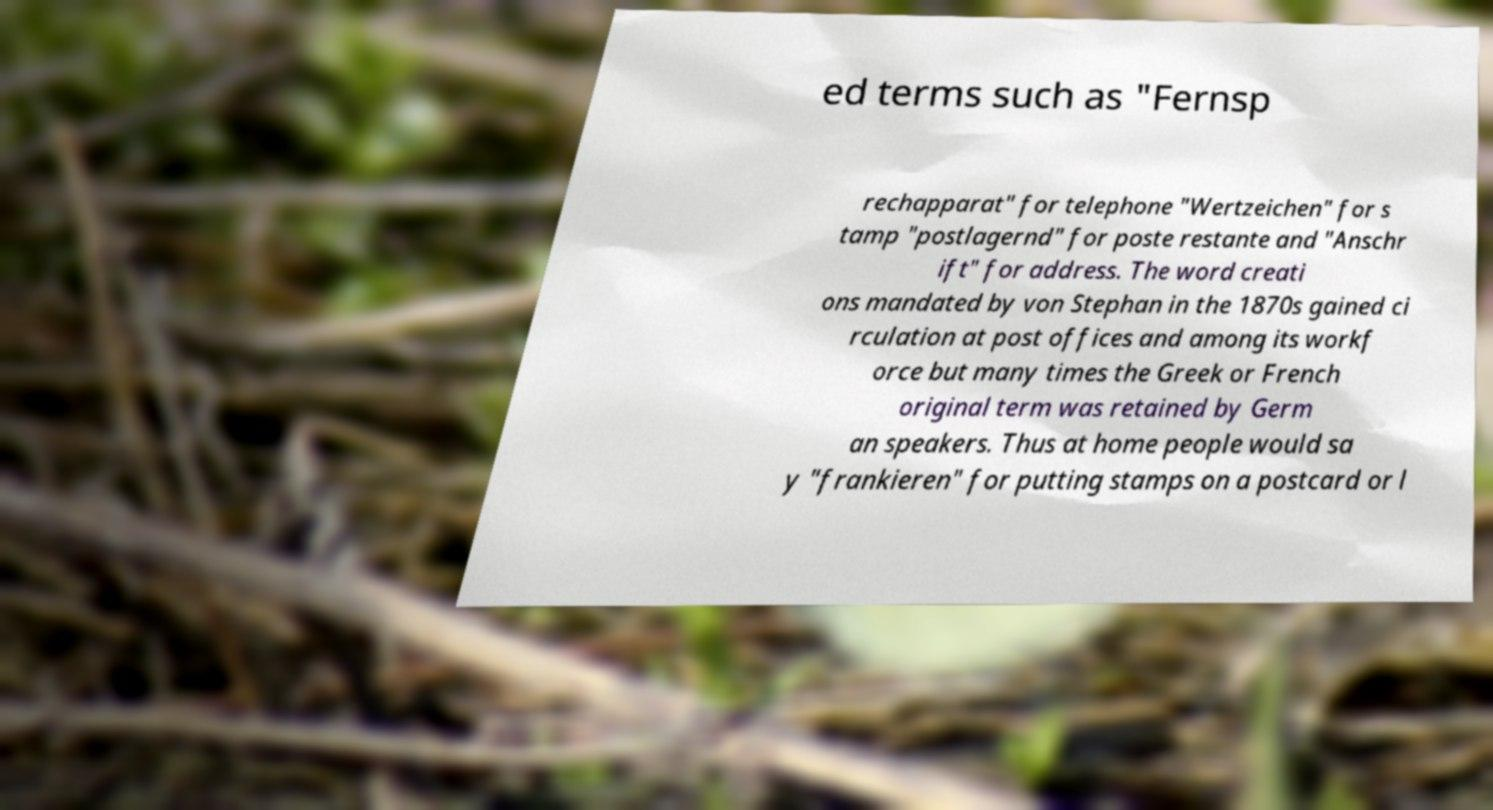I need the written content from this picture converted into text. Can you do that? ed terms such as "Fernsp rechapparat" for telephone "Wertzeichen" for s tamp "postlagernd" for poste restante and "Anschr ift" for address. The word creati ons mandated by von Stephan in the 1870s gained ci rculation at post offices and among its workf orce but many times the Greek or French original term was retained by Germ an speakers. Thus at home people would sa y "frankieren" for putting stamps on a postcard or l 